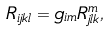Convert formula to latex. <formula><loc_0><loc_0><loc_500><loc_500>R _ { i j k l } = g _ { i m } R ^ { m } _ { j l k } ,</formula> 